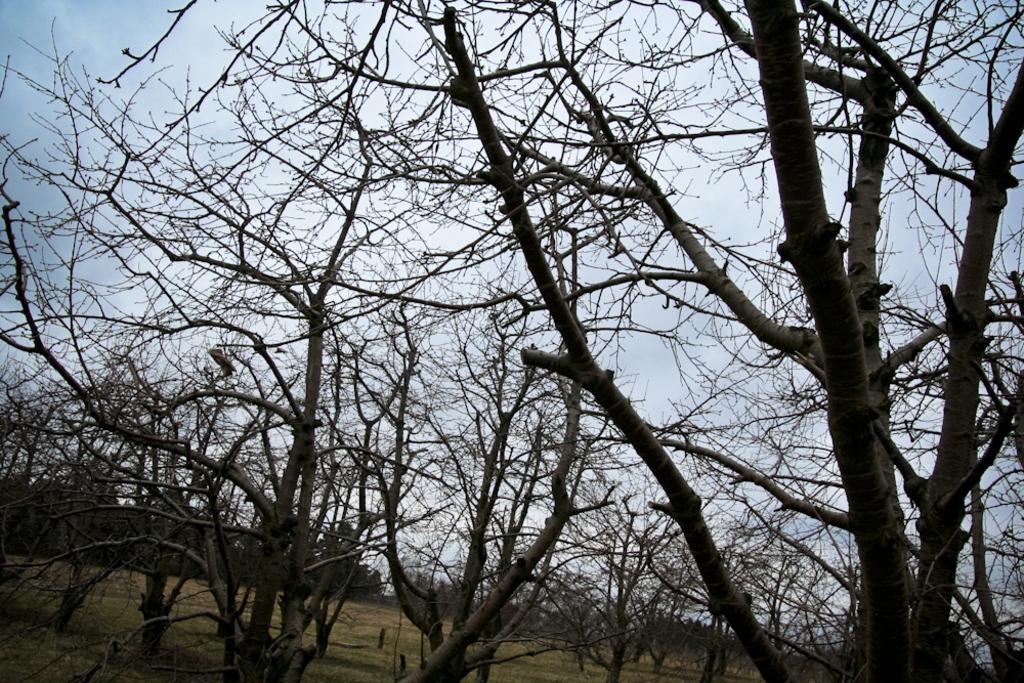Can you describe this image briefly? In the image there are many dry trees on the land and above its sky. 